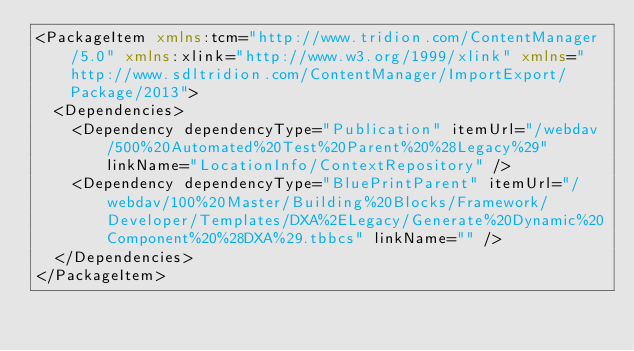<code> <loc_0><loc_0><loc_500><loc_500><_XML_><PackageItem xmlns:tcm="http://www.tridion.com/ContentManager/5.0" xmlns:xlink="http://www.w3.org/1999/xlink" xmlns="http://www.sdltridion.com/ContentManager/ImportExport/Package/2013">
  <Dependencies>
    <Dependency dependencyType="Publication" itemUrl="/webdav/500%20Automated%20Test%20Parent%20%28Legacy%29" linkName="LocationInfo/ContextRepository" />
    <Dependency dependencyType="BluePrintParent" itemUrl="/webdav/100%20Master/Building%20Blocks/Framework/Developer/Templates/DXA%2ELegacy/Generate%20Dynamic%20Component%20%28DXA%29.tbbcs" linkName="" />
  </Dependencies>
</PackageItem></code> 